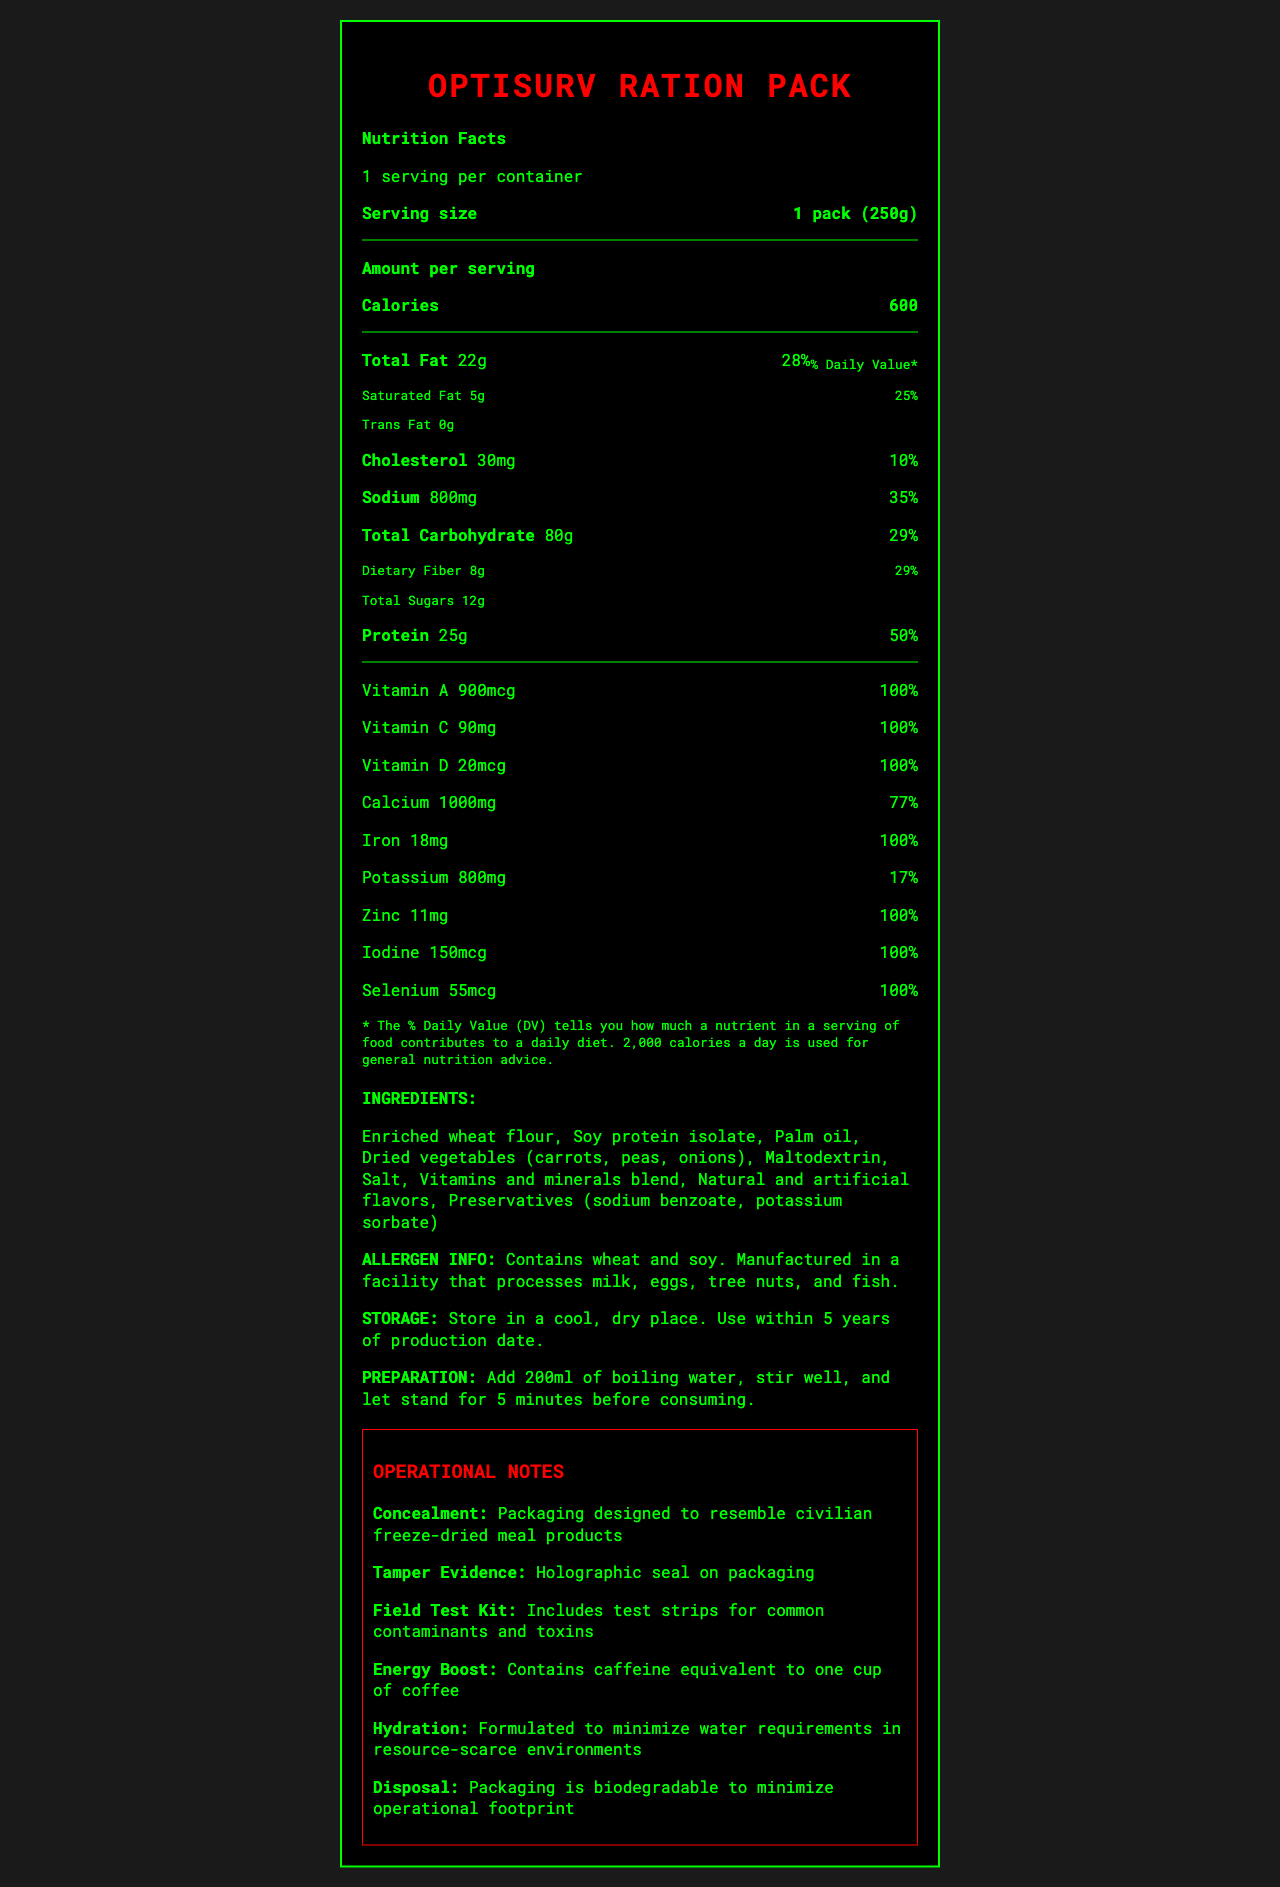what is the total fat content? The document specifies that the total fat content per serving is 22g.
Answer: 22g how much dietary fiber is in one serving? According to the document, each serving contains 8g of dietary fiber.
Answer: 8g what percentage of the daily value of vitamin D does one serving provide? The document indicates that one serving provides 100% of the daily value for vitamin D.
Answer: 100% what is the sodium content per serving? The sodium content per serving is listed as 800mg.
Answer: 800mg how many grams of protein are in each serving? The protein content per serving is provided as 25g.
Answer: 25g how long should you wait after adding boiling water before consuming the product? The preparation instructions state that you should add 200ml of boiling water, stir well, and let stand for 5 minutes before consuming.
Answer: 5 minutes what is the product name? The product name at the top of the document is "OptiSurv Ration Pack".
Answer: OptiSurv Ration Pack is the product manufactured in a facility that processes milk and eggs? The allergen information indicates that the product is manufactured in a facility that processes milk and eggs.
Answer: Yes what is the shelf life of the product? The document states that the product has a shelf life of 5 years.
Answer: 5 years which of the following minerals is included in the product? A. Copper B. Zinc C. Magnesium D. Phosphorus The document includes zinc as one of the minerals in the product, providing 11mg which is 100% of the daily value.
Answer: B. Zinc what are the three main components of the operational notes regarding the product? i. Concealment ii. Tamper evidence iii. Disposal iv. Cooking instructions v. Taste The operational notes discuss concealment, tamper evidence, and disposal.
Answer: i, ii, iii what is the weight of one pack of the product? A. 100g B. 250g C. 500g The document specifies that the serving size is 1 pack (250g).
Answer: B. 250g can the document tell you if the product contains any caffeine? The operational notes indicate that the product contains caffeine equivalent to one cup of coffee.
Answer: Yes how many servings are there per container? The document states that there is 1 serving per container.
Answer: 1 does the product contain any artificial flavors? The ingredients list includes "Natural and artificial flavors".
Answer: Yes describe the main nutritional components of the OptiSurv Ration Pack. The document outlines various nutritional elements per serving, including macronutrients (fats, carbohydrates, fiber, sugars, and protein) and micronutrients (vitamins and minerals) along with their respective amounts and daily values.
Answer: The OptiSurv Ration Pack provides 600 calories per serving, with key nutritional components including 22g of total fat, 80g of total carbohydrates, 8g of dietary fiber, 12g of total sugars, and 25g of protein. It also offers significant amounts of essential vitamins and minerals such as vitamin A, vitamin C, vitamin D, calcium, iron, zinc, iodine, and selenium. what is the production date of the product? The additional information section lists the production date as 2023-05-15.
Answer: 2023-05-15 